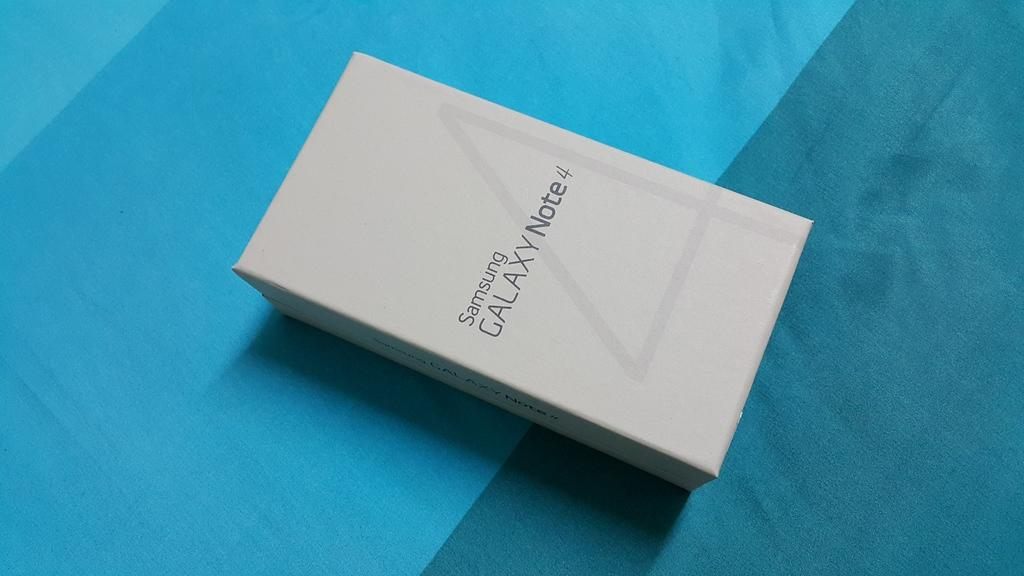<image>
Relay a brief, clear account of the picture shown. A white box with the writing Samsung Galaxy Note 4 sits on a table wit a blue cloth. 